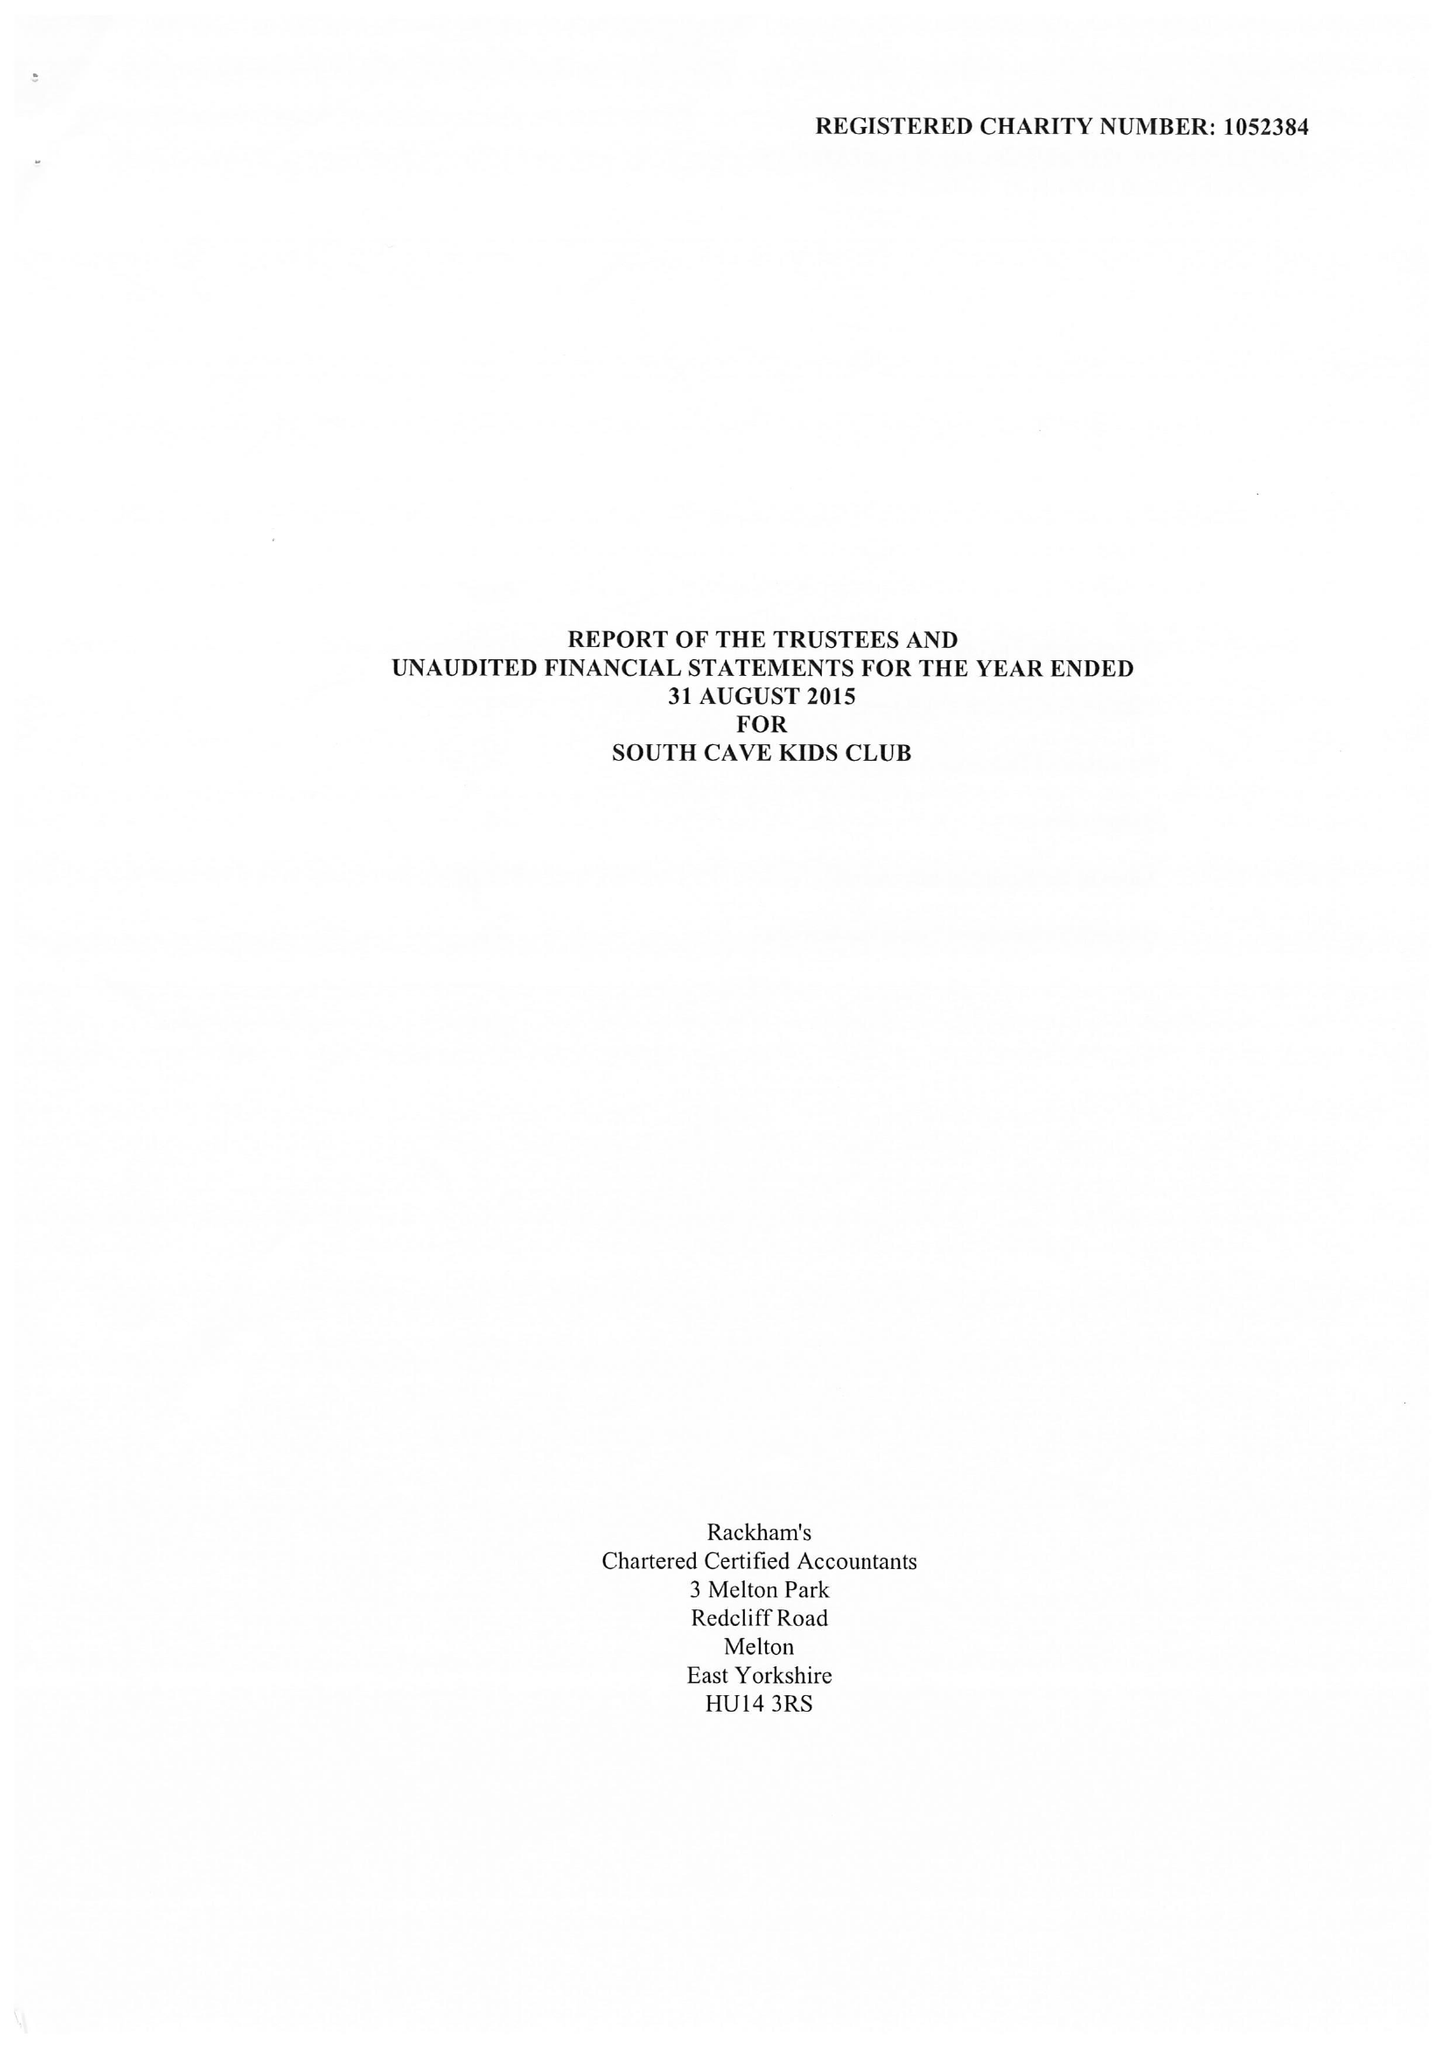What is the value for the address__postcode?
Answer the question using a single word or phrase. HU15 2EP 